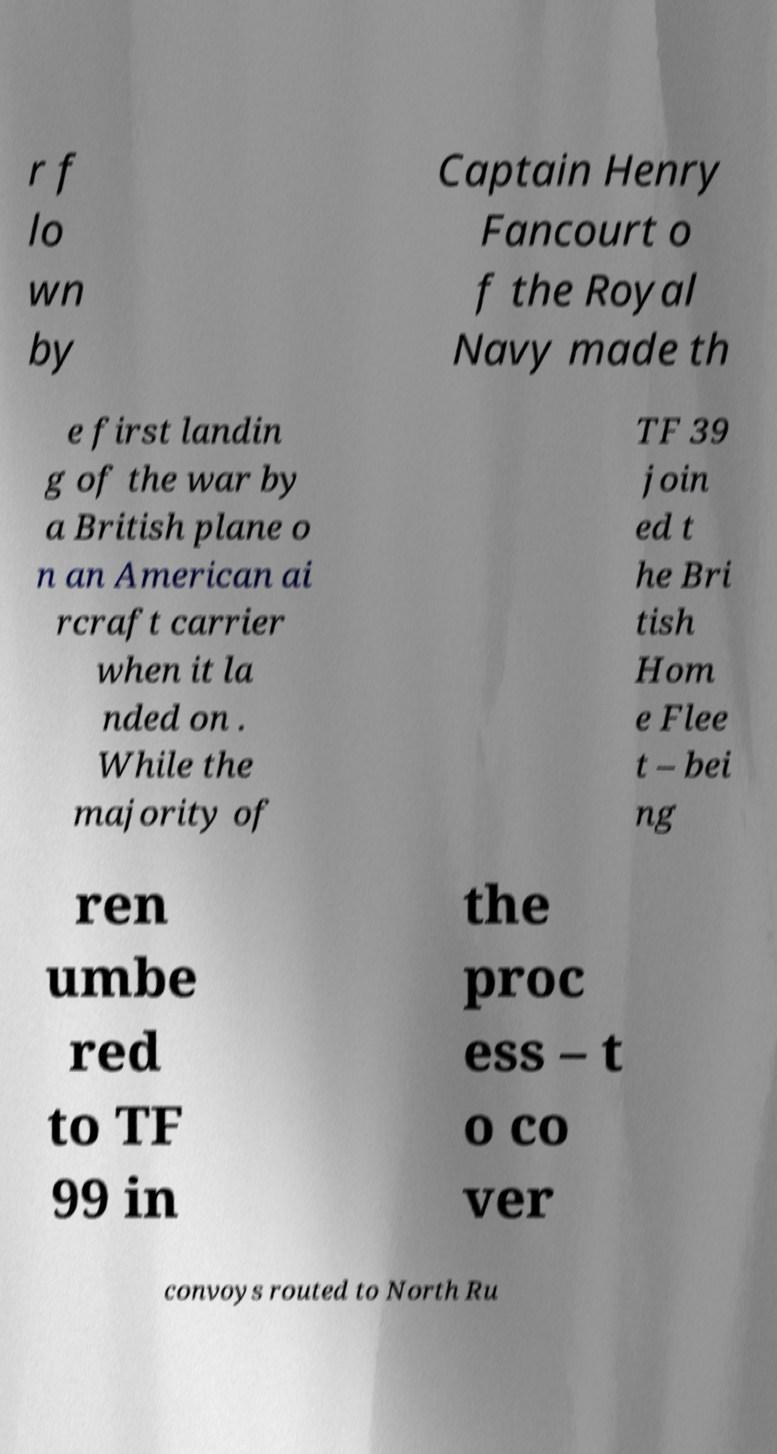Can you read and provide the text displayed in the image?This photo seems to have some interesting text. Can you extract and type it out for me? r f lo wn by Captain Henry Fancourt o f the Royal Navy made th e first landin g of the war by a British plane o n an American ai rcraft carrier when it la nded on . While the majority of TF 39 join ed t he Bri tish Hom e Flee t – bei ng ren umbe red to TF 99 in the proc ess – t o co ver convoys routed to North Ru 